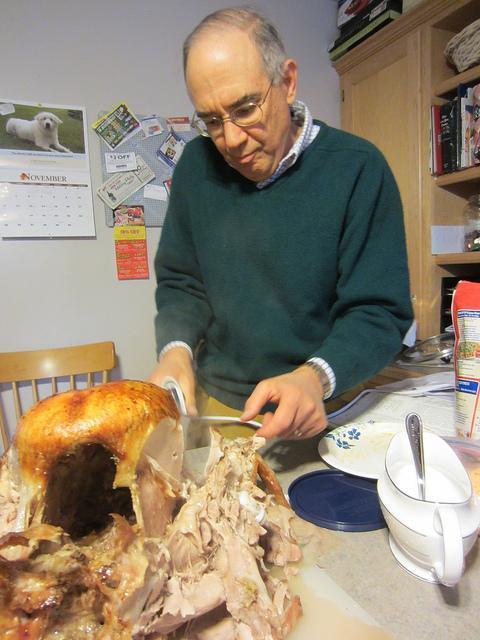How many dining tables can you see?
Give a very brief answer. 1. How many people are there?
Give a very brief answer. 1. 